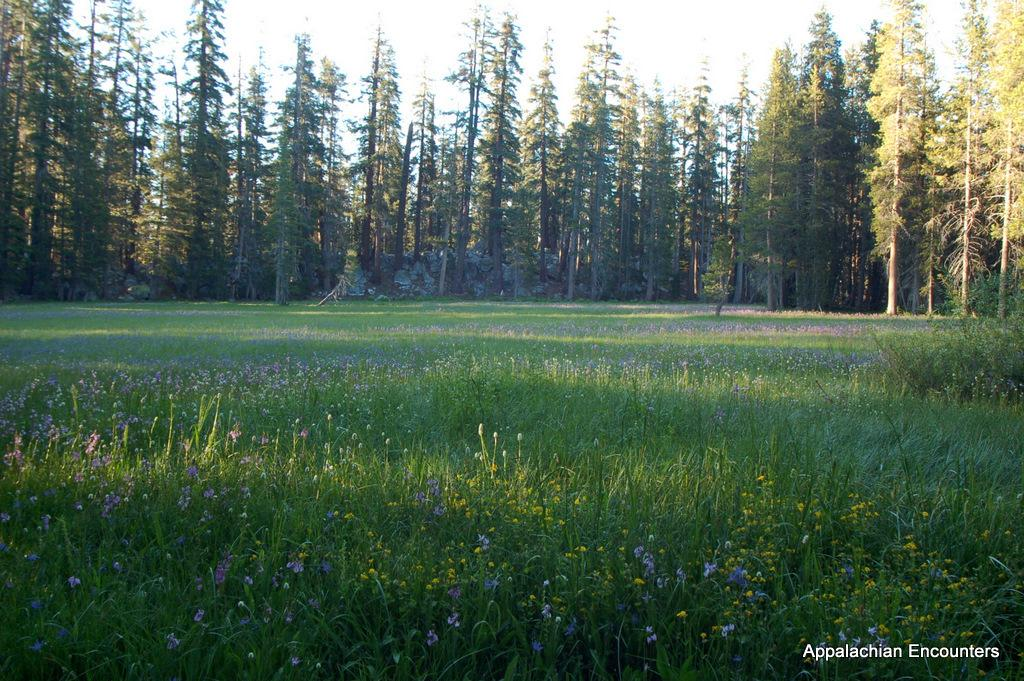What can be seen in the foreground of the image? There is a field of plants and flowers in the foreground of the image. What other natural elements are present in the image? There are trees in the middle of the image. What is visible at the top of the image? The sky is visible at the top of the image. What type of circle can be seen on the ground in the image? There is no circle present on the ground in the image. What cast is visible in the sky in the image? There is no cast visible in the sky in the image. 